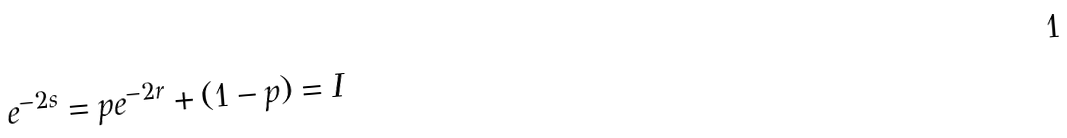<formula> <loc_0><loc_0><loc_500><loc_500>e ^ { - 2 s } = p e ^ { - 2 r } + ( 1 - p ) = I</formula> 